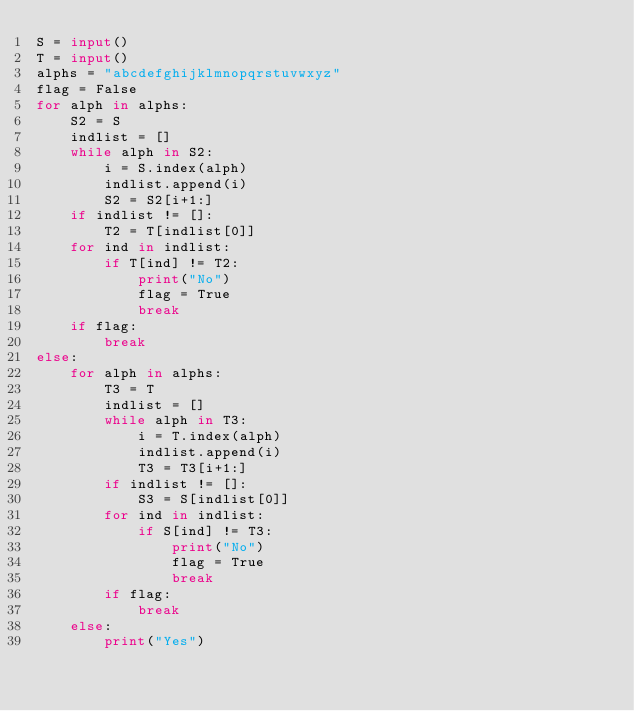<code> <loc_0><loc_0><loc_500><loc_500><_Python_>S = input()
T = input()
alphs = "abcdefghijklmnopqrstuvwxyz"
flag = False
for alph in alphs:
    S2 = S
    indlist = []
    while alph in S2:
        i = S.index(alph)
        indlist.append(i)
        S2 = S2[i+1:]
    if indlist != []:
        T2 = T[indlist[0]]
    for ind in indlist:
        if T[ind] != T2:
            print("No")
            flag = True
            break
    if flag:
        break
else:
    for alph in alphs:
        T3 = T
        indlist = []
        while alph in T3:
            i = T.index(alph)
            indlist.append(i)
            T3 = T3[i+1:]
        if indlist != []:
            S3 = S[indlist[0]]
        for ind in indlist:
            if S[ind] != T3:
                print("No")
                flag = True
                break
        if flag:
            break
    else:
        print("Yes")
</code> 